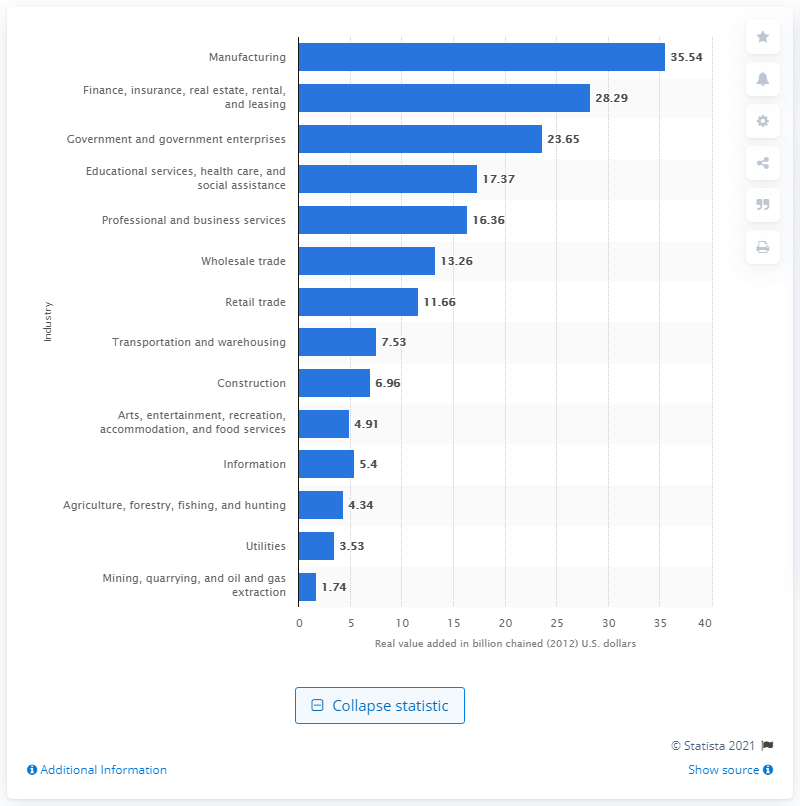Could you discuss the mid-range industries and their contributions to Kentucky's GDP? Certainly! The mid-range industries include Professional and business services, Wholesale trade, and Retail trade, contributing 16.36, 13.26, and 11.66 billion chained 2012 U.S. dollars, respectively. These figures indicate that while these sectors are not at the very top, they also play significant roles in Kentucky's economic landscape. 